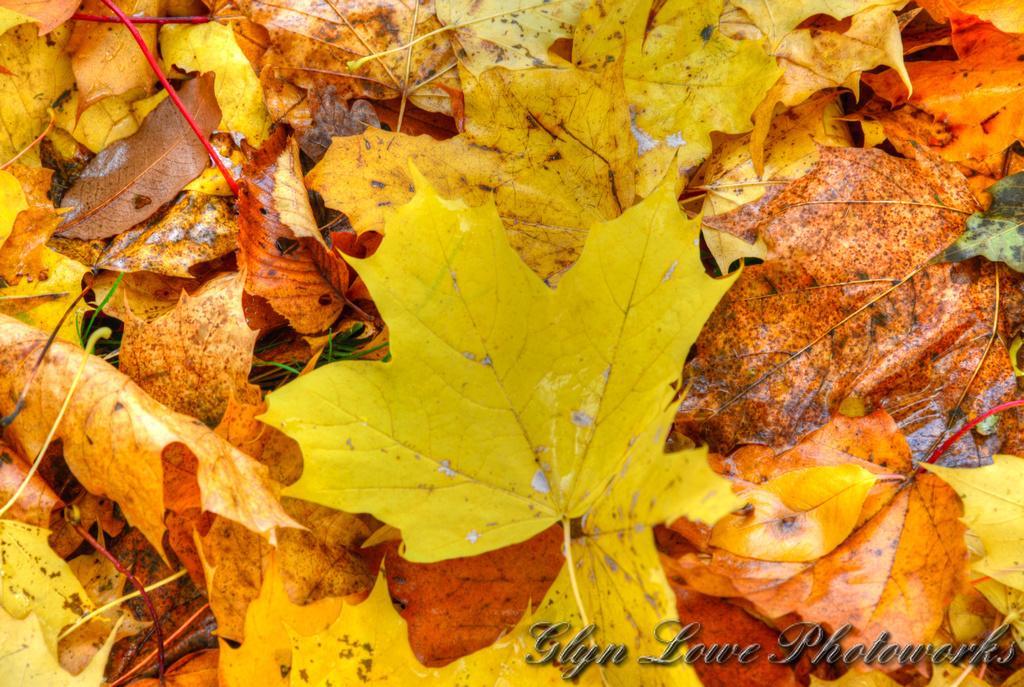Please provide a concise description of this image. In this image we can see some leaves, also we can see some text. 